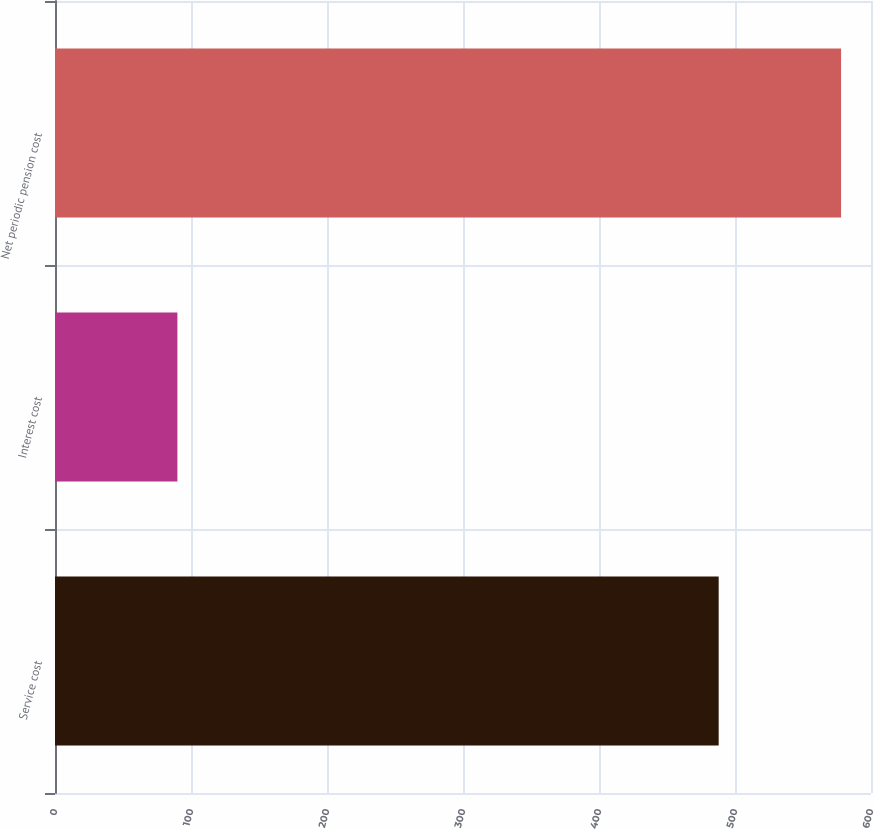Convert chart. <chart><loc_0><loc_0><loc_500><loc_500><bar_chart><fcel>Service cost<fcel>Interest cost<fcel>Net periodic pension cost<nl><fcel>488<fcel>90<fcel>578<nl></chart> 